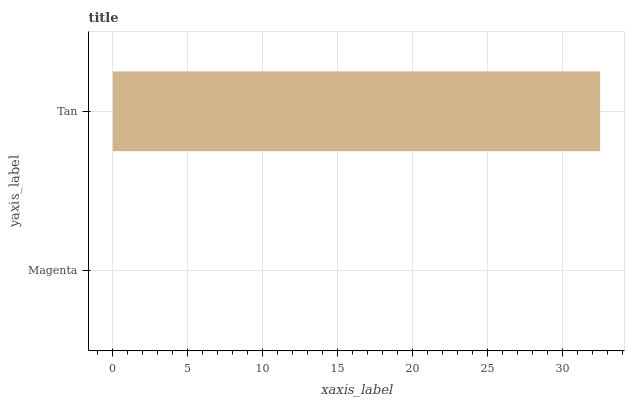Is Magenta the minimum?
Answer yes or no. Yes. Is Tan the maximum?
Answer yes or no. Yes. Is Tan the minimum?
Answer yes or no. No. Is Tan greater than Magenta?
Answer yes or no. Yes. Is Magenta less than Tan?
Answer yes or no. Yes. Is Magenta greater than Tan?
Answer yes or no. No. Is Tan less than Magenta?
Answer yes or no. No. Is Tan the high median?
Answer yes or no. Yes. Is Magenta the low median?
Answer yes or no. Yes. Is Magenta the high median?
Answer yes or no. No. Is Tan the low median?
Answer yes or no. No. 